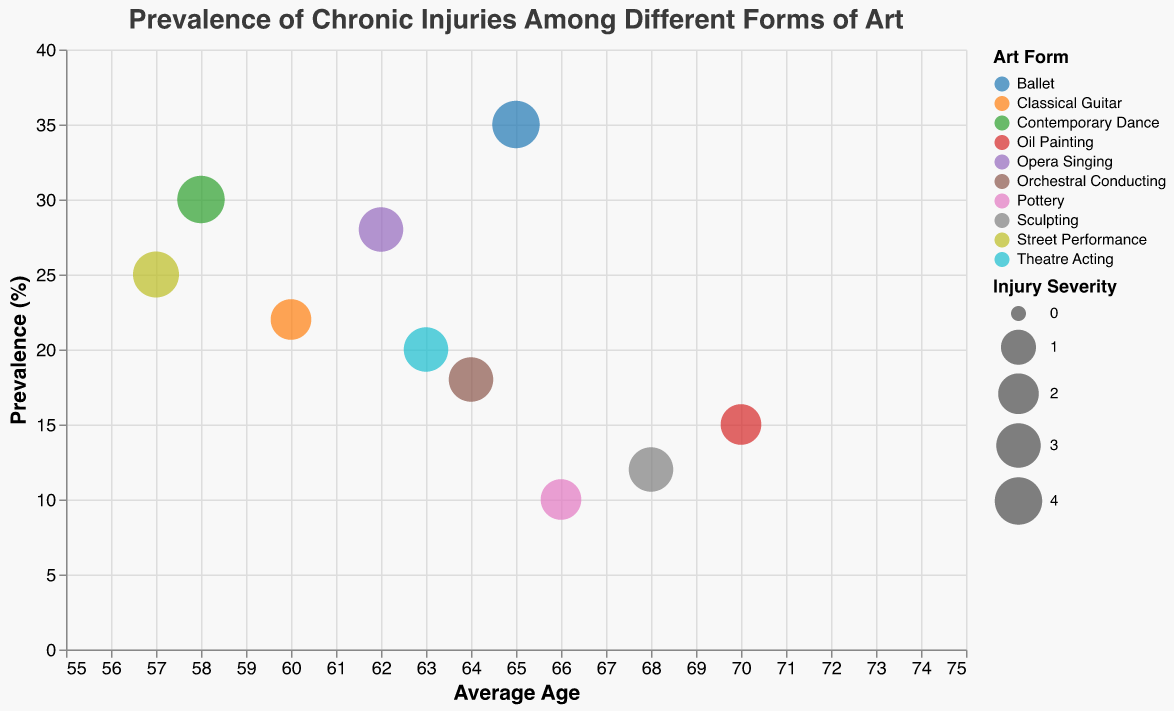How many different art forms are represented in the figure? Count the number of unique color bubbles, each representing a different art form. There are 10 unique bubbles.
Answer: 10 Which art form shows the highest prevalence of chronic injuries? The bubble at the highest vertical position (Prevalence percentage) corresponds to the highest prevalence. Ballet is at 35%.
Answer: Ballet What is the average age of artists involved in street performance? Locate the bubble for street performance and read its corresponding average age on the x-axis. The average age is 57.
Answer: 57 Which art form has the lowest injury severity? Find the smallest bubble size on the plot, which indicates the lowest injury severity. Oil Painting and Pottery both have an injury severity of 2.
Answer: Oil Painting, Pottery How does the prevalence of chronic injuries in contemporary dance compare to opera singing? Locate the bubbles for contemporary dance (30%) and opera singing (28%) and compare their vertical positions. Contemporary Dance has a slightly higher prevalence.
Answer: Contemporary Dance > Opera Singing What is the combined prevalence of chronic injuries for ballet, opera singing, and street performance? Sum their prevalence percentages: Ballet (35%) + Opera Singing (28%) + Street Performance (25%). The total is 35 + 28 + 25 = 88%.
Answer: 88% Which art form has artists with the oldest average age? Identify the bubble furthest to the right on the x-axis, indicating the oldest average age. Oil Painting has an average age of 70.
Answer: Oil Painting What is the difference in average age between the youngest and oldest art forms? Identify the youngest (Street Performance, 57) and oldest (Oil Painting, 70) average ages. The difference is 70 - 57 = 13 years.
Answer: 13 years Which art form has a higher injury severity: classical guitar or theatre acting? Compare the bubble sizes of classical guitar (2) and theatre acting (3). Theatre Acting has a higher severity.
Answer: Theatre Acting Is the injury severity for contemporary dance more severe than for sculpting? Compare the bubble sizes for contemporary dance (4) and sculpting (3). Contemporary Dance has a higher injury severity.
Answer: Yes 